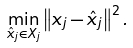Convert formula to latex. <formula><loc_0><loc_0><loc_500><loc_500>\min _ { \hat { x } _ { j } \in X _ { j } } \left \| x _ { j } - \hat { x } _ { j } \right \| ^ { 2 } .</formula> 